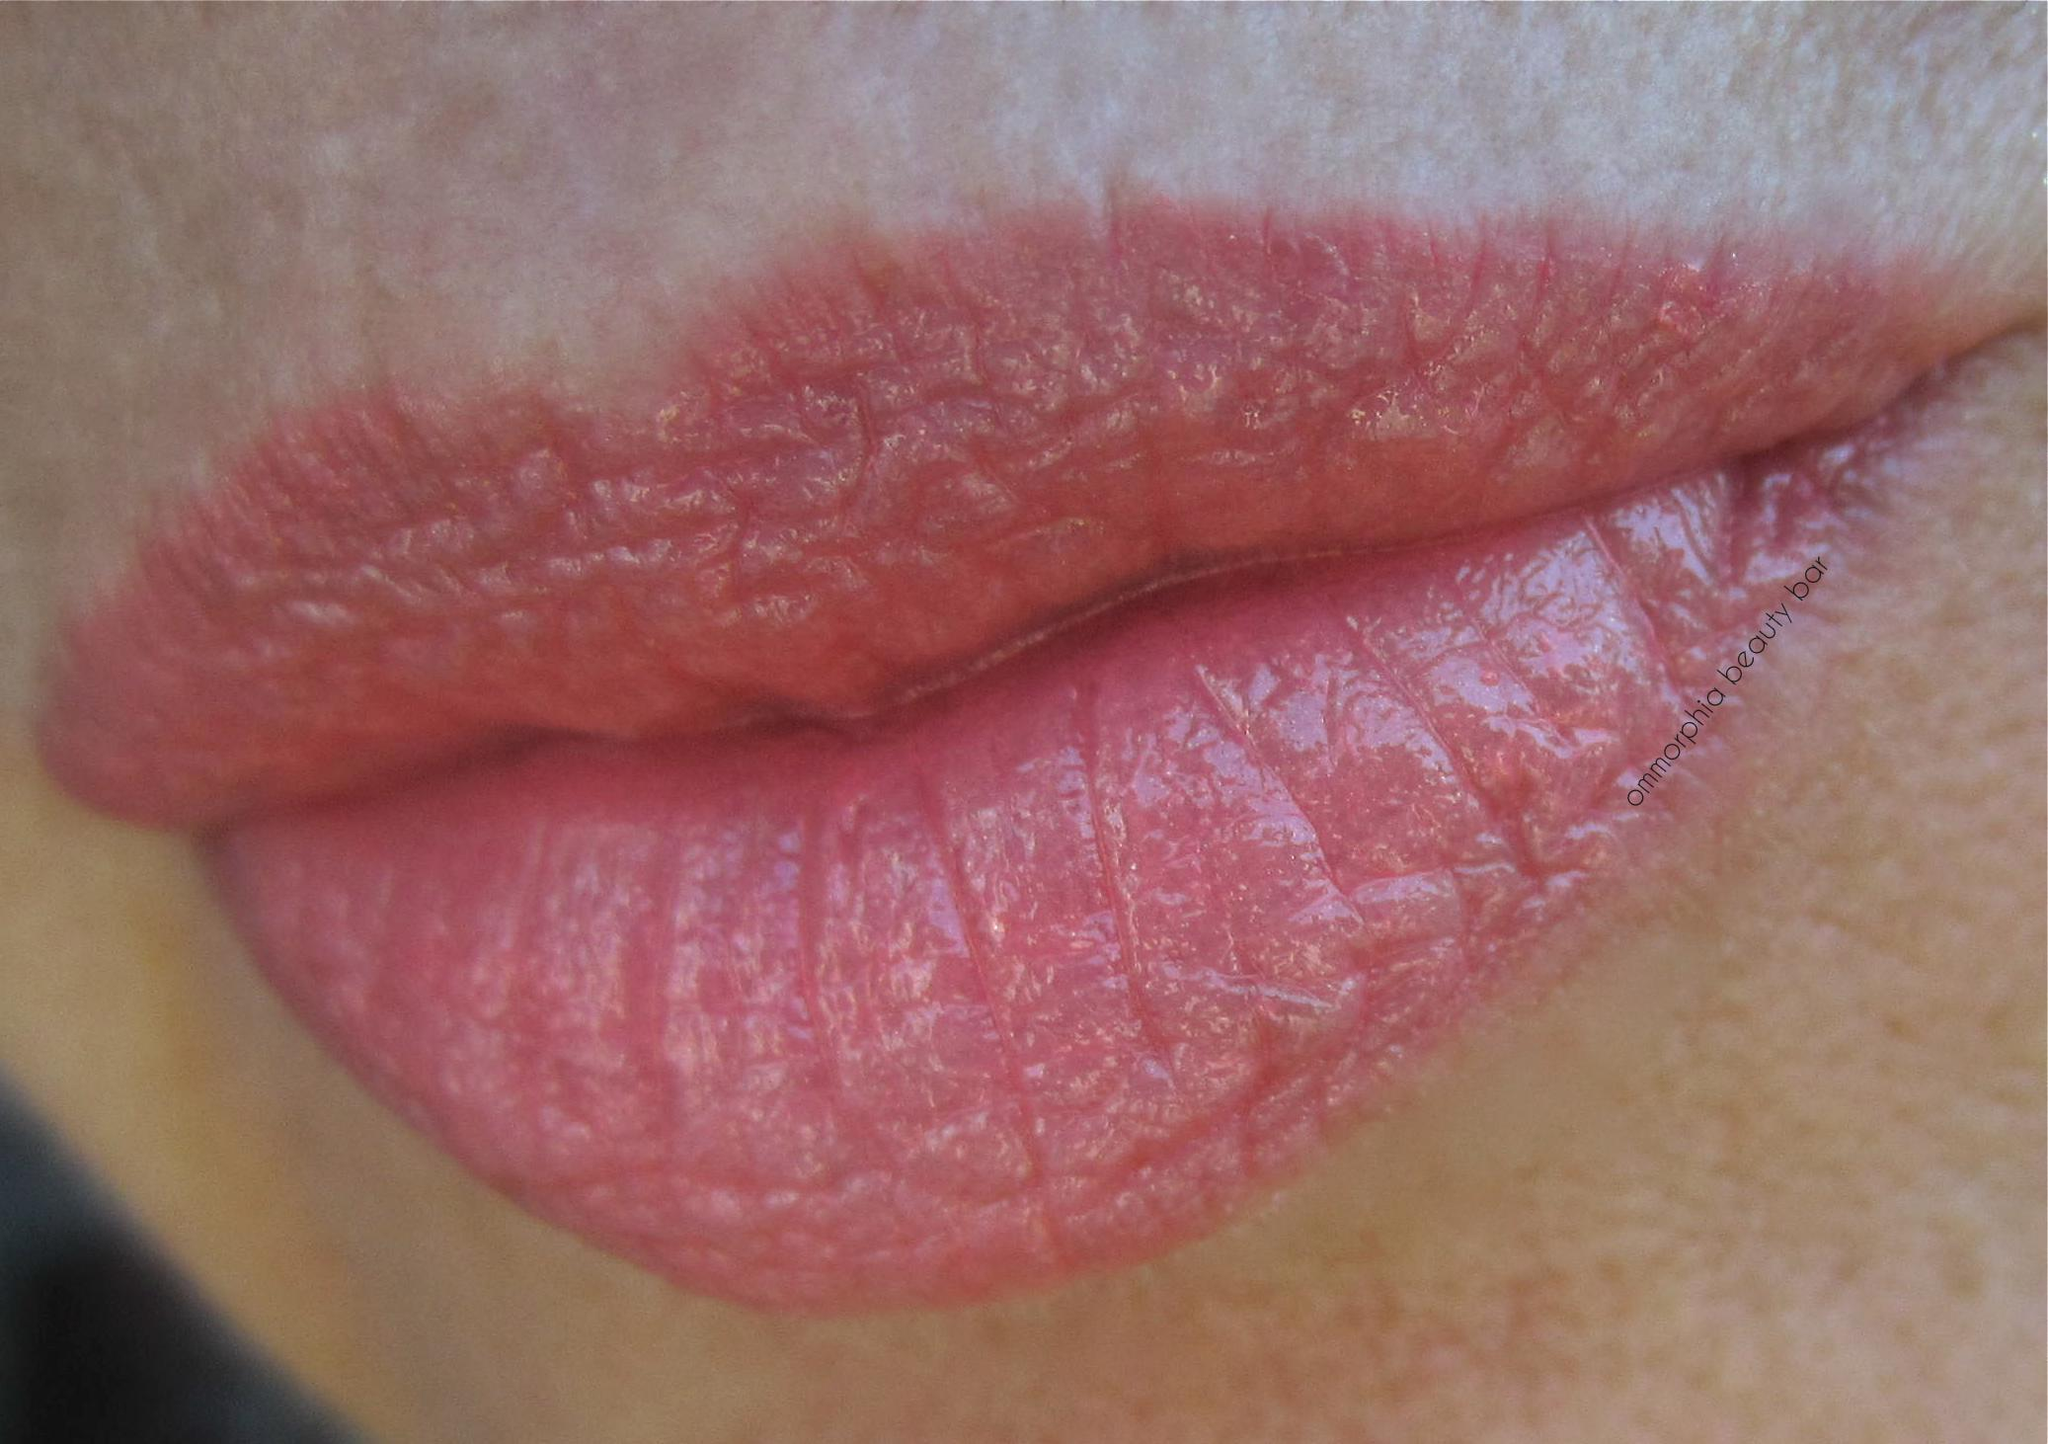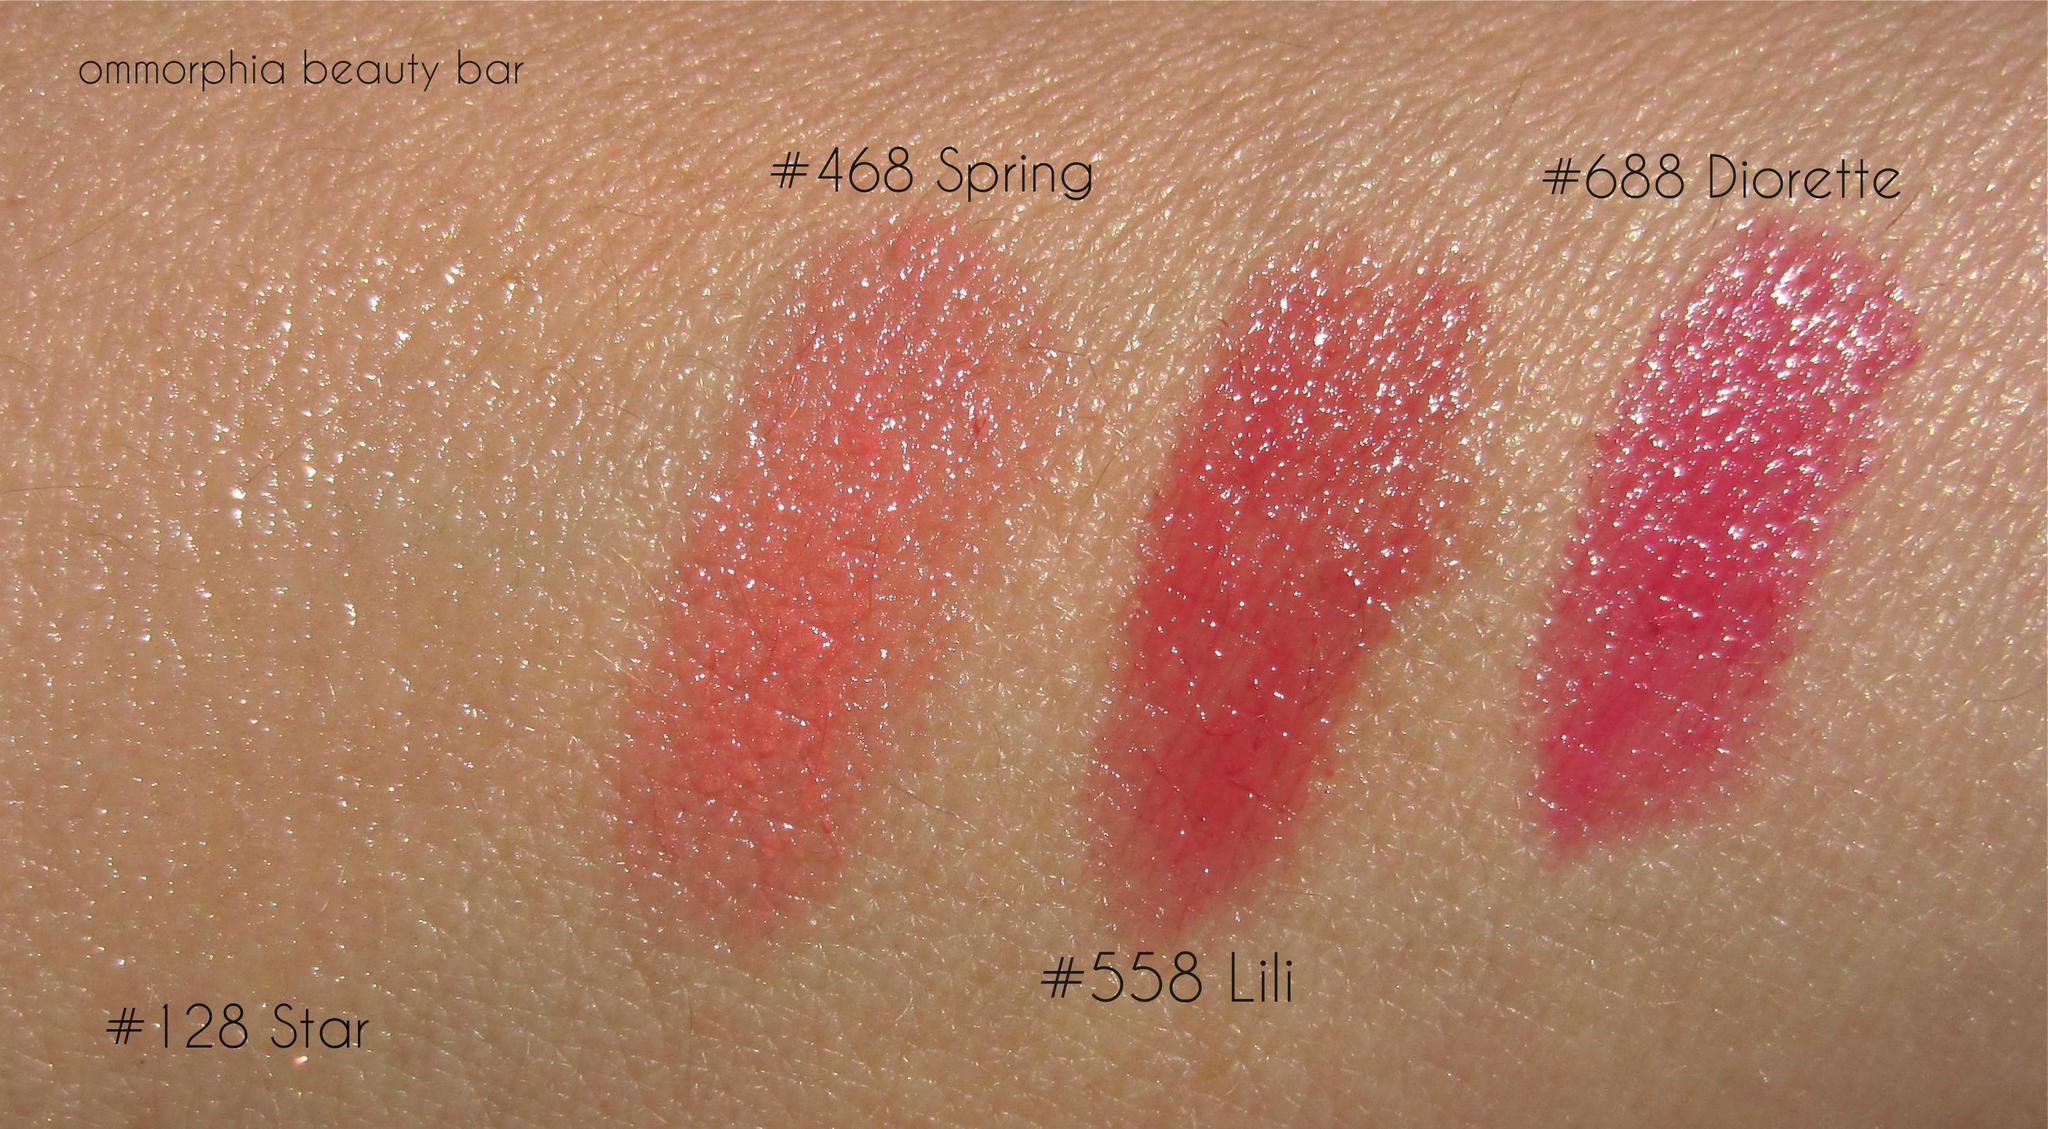The first image is the image on the left, the second image is the image on the right. Evaluate the accuracy of this statement regarding the images: "Atleast 1 pair of lips can be seen.". Is it true? Answer yes or no. Yes. The first image is the image on the left, the second image is the image on the right. Analyze the images presented: Is the assertion "At least one of the images shows a woman's lips." valid? Answer yes or no. Yes. 